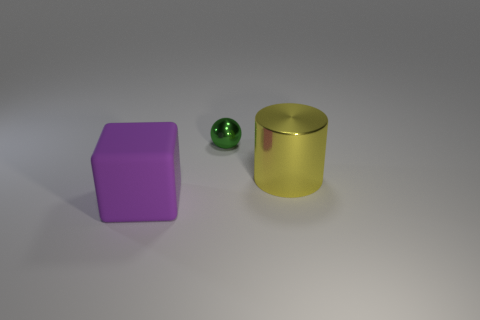What can you say about the materials of the objects? The sphere and the cylinder exhibit reflective surfaces and likely consist of a metallic material. The cube, however, has a matte finish indicating a non-metallic, possibly plastic or painted surface. Which object looks the smoothest to the touch? The sphere looks the smoothest given its uninterrupted rounded surface, with the cylinder following close due to its polished surface. The cube has visible edges and vertices which make it less smooth compared. 